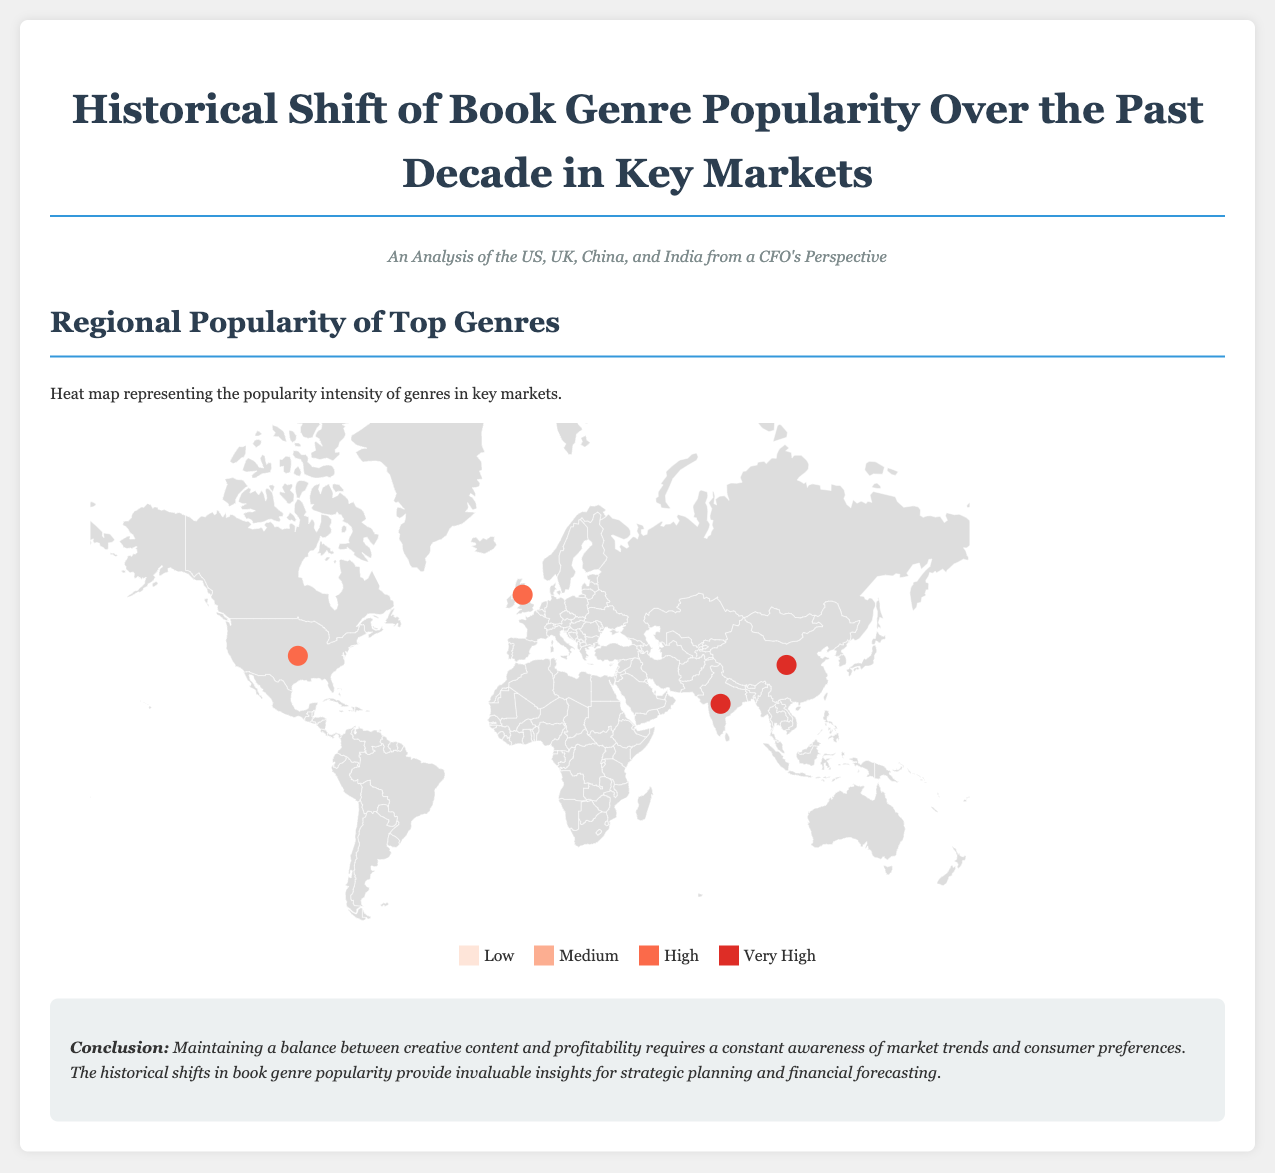what genre is most popular in India? According to the heat map and data, the most popular genre in India is Self-Help with a score of 25.
Answer: Self-Help which country has the highest popularity for Non-Fiction genre? The heat map indicates that China has the highest popularity for the Non-Fiction genre, scoring 25.
Answer: China what color represents "Very High" popularity in the heat map? The color representing "Very High" popularity in the heat map is red (#de2d26).
Answer: red how many top genres are mentioned for the United States? The data lists three top genres for the United States: Mystery & Thriller, Science Fiction, and Fantasy.
Answer: three what is the primary takeaway from the conclusion section? The conclusion emphasizes the need for awareness of market trends and consumer preferences to balance creativity and profitability.
Answer: awareness of market trends which genre has a high popularity score in both China and India? The genre that has a high popularity score in both China and India is Mystery & Thriller. China scores 23 while India scores 22.
Answer: Mystery & Thriller what is the main purpose of the infographic? The main purpose of the infographic is to analyze historical shifts in book genre popularity in key markets for strategic insights.
Answer: strategic insights which genre gained popularity in the United Kingdom? The genre that gained popularity in the United Kingdom is Science Fiction, scoring 20.
Answer: Science Fiction what shape is used to represent countries on the map? The map uses paths to represent countries, highlighting geographical boundaries.
Answer: paths 